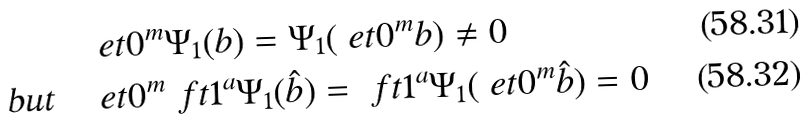Convert formula to latex. <formula><loc_0><loc_0><loc_500><loc_500>& \ e t { 0 } ^ { m } \Psi _ { 1 } ( b ) = \Psi _ { 1 } ( \ e t { 0 } ^ { m } b ) \neq 0 \\ \text {but} \quad & \ e t { 0 } ^ { m } \ f t { 1 } ^ { a } \Psi _ { 1 } ( \hat { b } ) = \ f t { 1 } ^ { a } \Psi _ { 1 } ( \ e t { 0 } ^ { m } \hat { b } ) = 0</formula> 